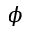Convert formula to latex. <formula><loc_0><loc_0><loc_500><loc_500>\phi</formula> 